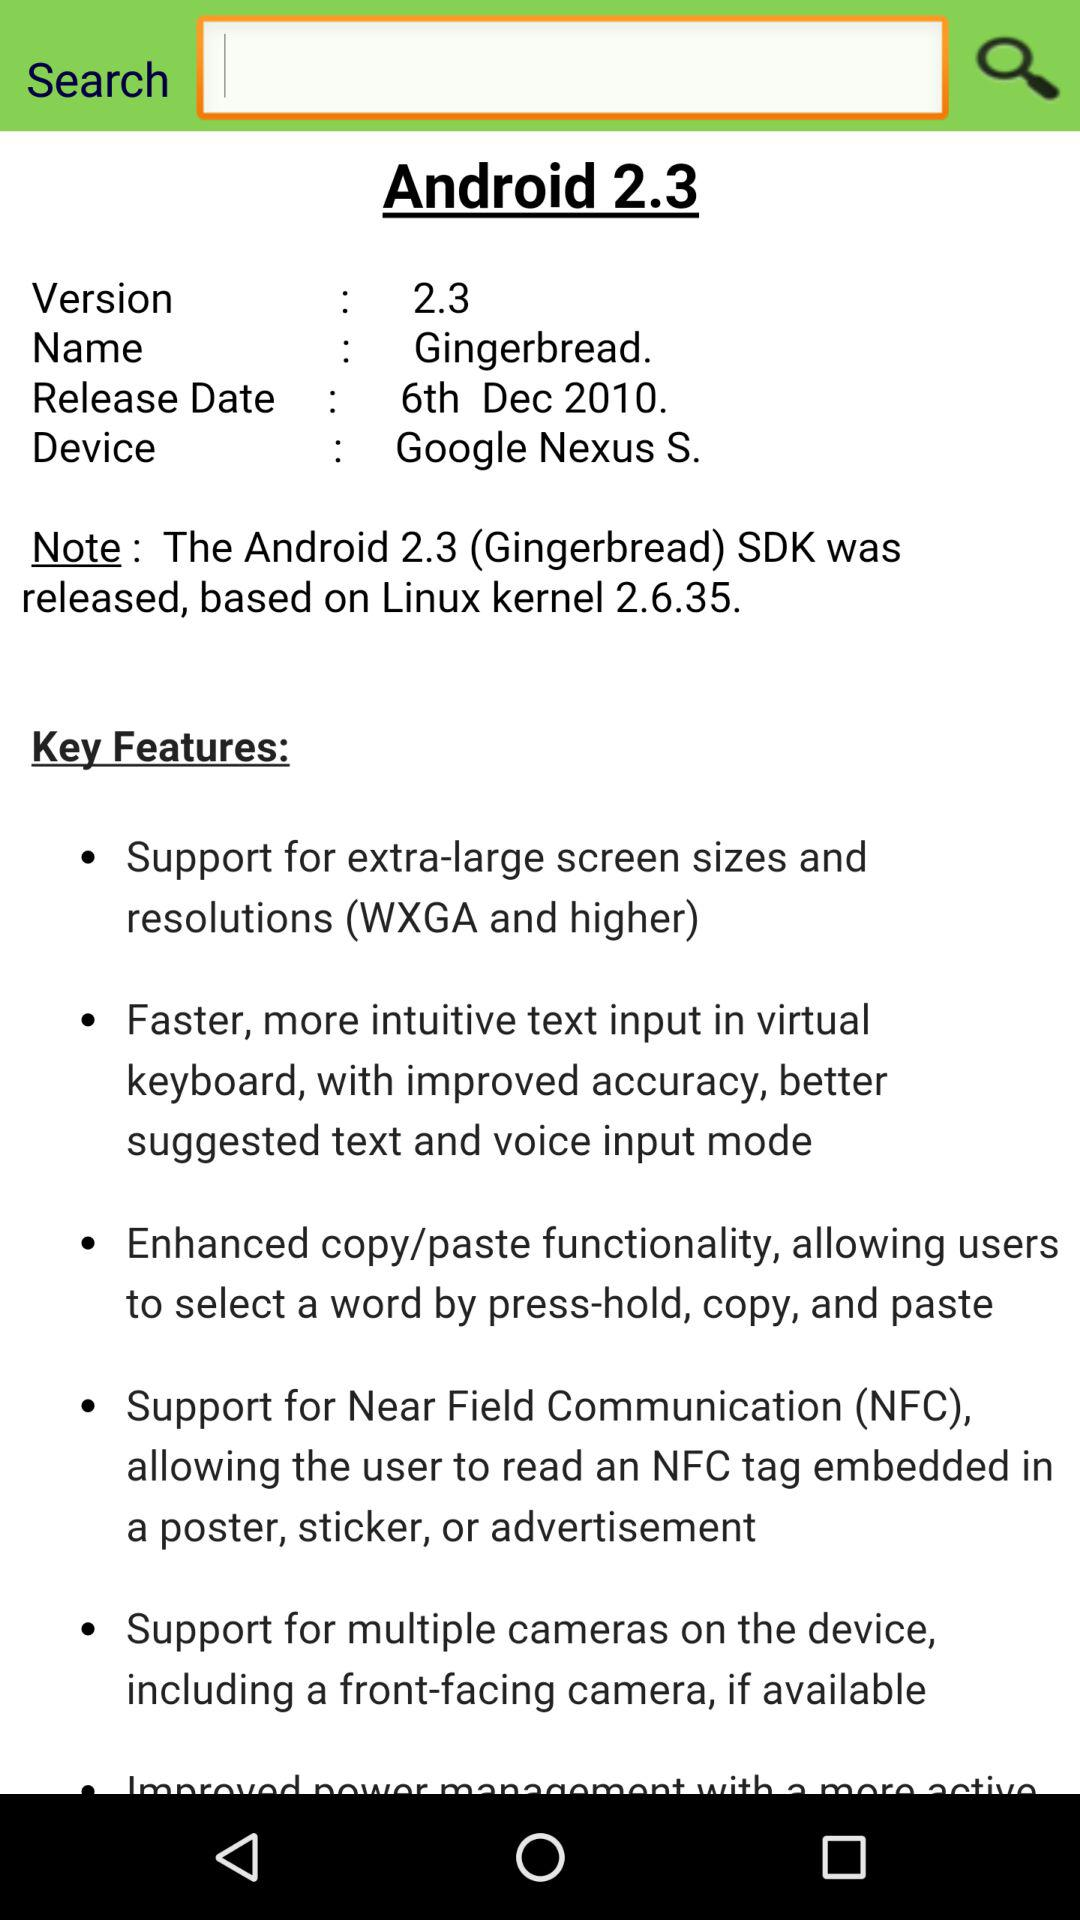What is the full form of NFC? The full form of NFC is Near Field Communication. 